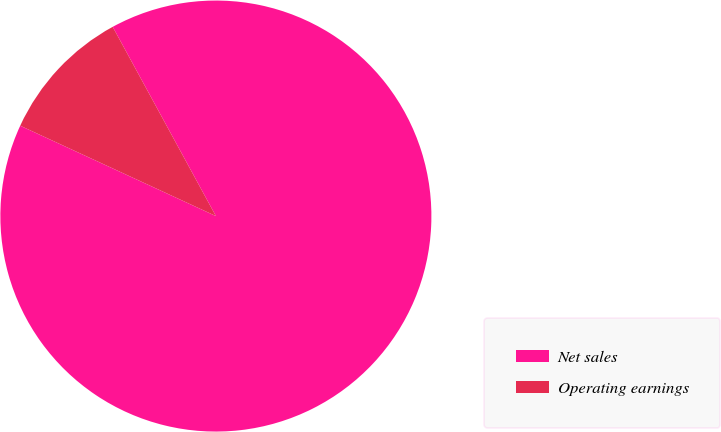Convert chart to OTSL. <chart><loc_0><loc_0><loc_500><loc_500><pie_chart><fcel>Net sales<fcel>Operating earnings<nl><fcel>89.83%<fcel>10.17%<nl></chart> 